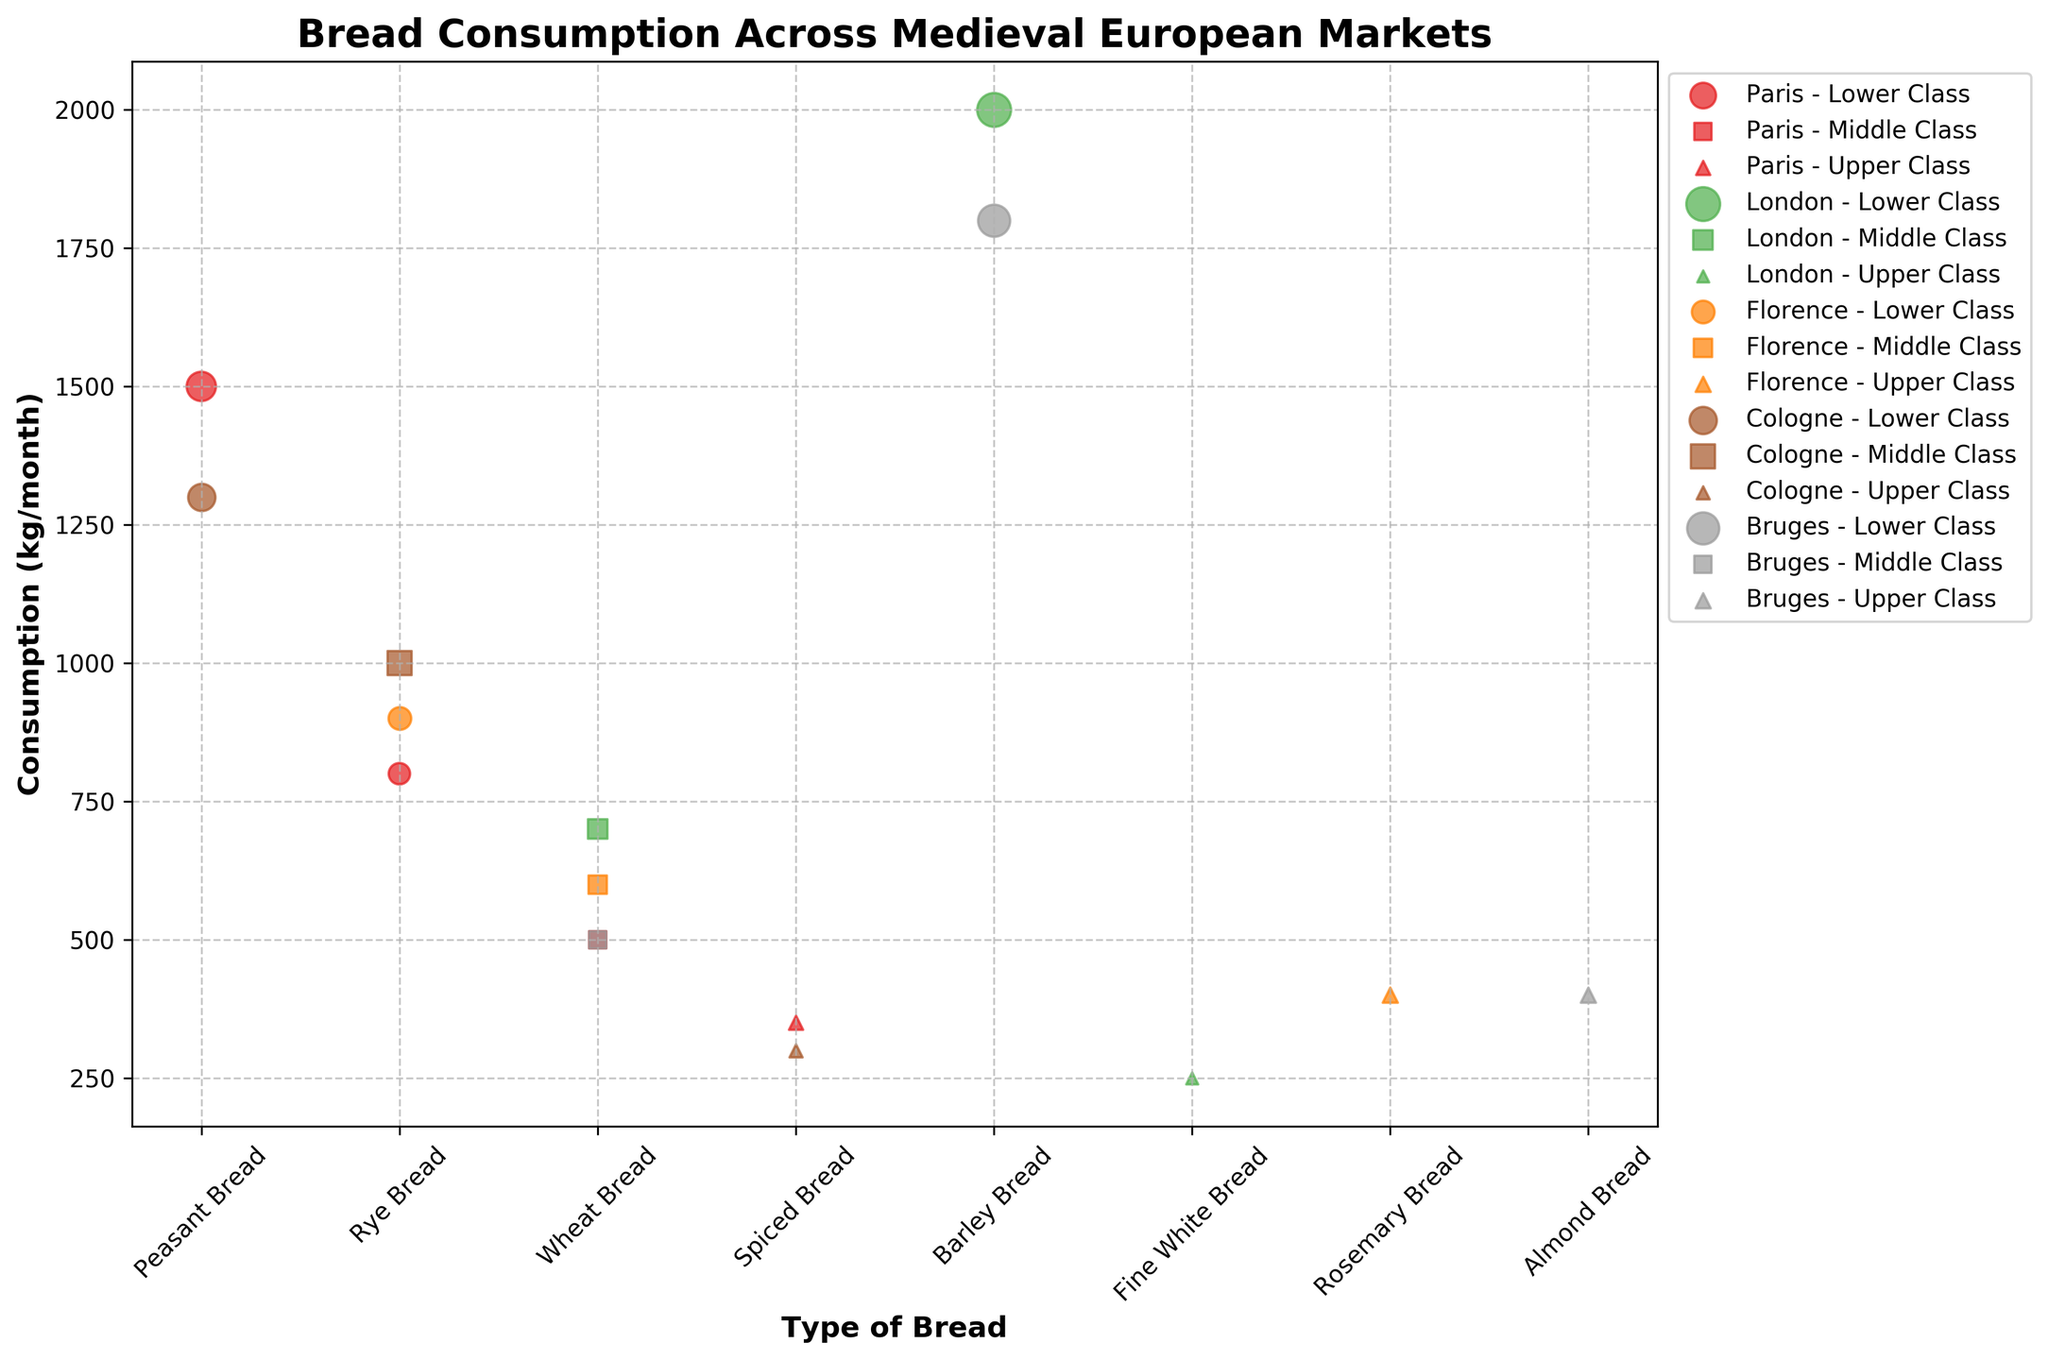What's the title of the figure? The title is prominently displayed at the top of the figure and reads "Bread Consumption Across Medieval European Markets".
Answer: Bread Consumption Across Medieval European Markets What are the axes labels of the scatter plot? The x-axis is labeled "Type of Bread", and the y-axis is labeled "Consumption (kg/month)". These labels are shown horizontally and vertically next to the respective axes.
Answer: Type of Bread; Consumption (kg/month) Which market has the highest aggregate bread consumption? To find the highest aggregate bread consumption, calculate the sum of 'Consumption (kg/month)' for each market. Paris: 1500 + 800 + 500 + 350 = 3150; London: 2000 + 700 + 250 = 2950; Florence: 900 + 600 + 400 = 1900; Cologne: 1300 + 1000 + 300 = 2600; Bruges: 1800 + 500 + 400 = 2700. Paris has the highest total consumption.
Answer: Paris For the lower class in Paris, what type of bread is consumed the least? From the figure, examine the data points representing the lower class in Paris which are indicated with circle markers. Compare their y-values (Consumption in kg/month). Rye Bread (800 kg/month) is consumed the least among "Peasant Bread" (1500 kg/month) and "Rye Bread".
Answer: Rye Bread Compare the wheat bread consumption between London and Florence. Which city consumes more? Using the wheat bread data points marked with squares for middle class in each city: London consumes 700 kg/month, and Florence consumes 600 kg/month. London consumes more wheat bread.
Answer: London Which class in Bruges consumes Almond Bread and how much is consumed? In the scatter plot, Almond Bread corresponds to a data point in Bruges, identified by an upward triangle marker. This marker represents the upper class, and the consumption is noted as 400 kg/month.
Answer: Upper Class, 400 kg/month Which type of bread has the highest consumption for the upper class in any market? Look for the highest data point with an upward triangle marker representing the upper class across all markets. The highest upward triangle is Fine White Bread in London with 250 kg/month.
Answer: Fine White Bread What is the average bread consumption for the lower class across all markets? Calculate the total consumption for lower class across all data points with circle markers: 1500 (Paris) + 800 (Paris) + 2000 (London) + 900 (Florence) + 1300 (Cologne) + 1800 (Bruges) = 8300 kg/month. Divide by the number of markets (5): 8300 / 6 = 1383.33 kg/month.
Answer: 1383.33 kg/month What type of bread is only consumed by the middle class in Cologne? For Cologne, examine the square markers for middle class. There is one data point for Rye Bread at 1000 kg/month, which is exclusive to the middle class in Cologne.
Answer: Rye Bread 